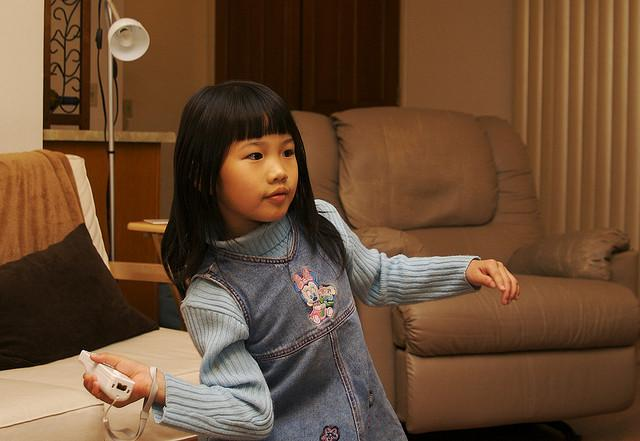Who created the character on the girls dress? disney 